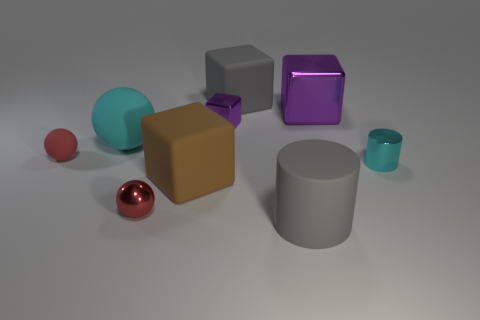Is the color of the metal cylinder the same as the large ball?
Provide a succinct answer. Yes. What size is the cyan metallic cylinder?
Provide a short and direct response. Small. There is a red metal thing that is the same shape as the tiny rubber object; what is its size?
Provide a short and direct response. Small. There is a cyan thing that is to the left of the gray matte cylinder; how many large brown rubber cubes are on the left side of it?
Offer a terse response. 0. Does the large gray thing that is in front of the big purple cube have the same material as the cyan thing on the right side of the tiny cube?
Your response must be concise. No. How many other things have the same shape as the big cyan matte thing?
Ensure brevity in your answer.  2. What number of big blocks are the same color as the metallic ball?
Your answer should be very brief. 0. Is the shape of the purple thing that is behind the small purple cube the same as the big gray rubber object behind the cyan matte object?
Your answer should be very brief. Yes. How many purple metallic objects are right of the cube on the right side of the block behind the big purple object?
Keep it short and to the point. 0. The tiny object that is in front of the rubber cube that is in front of the big matte cube on the right side of the small purple metallic cube is made of what material?
Your answer should be very brief. Metal. 